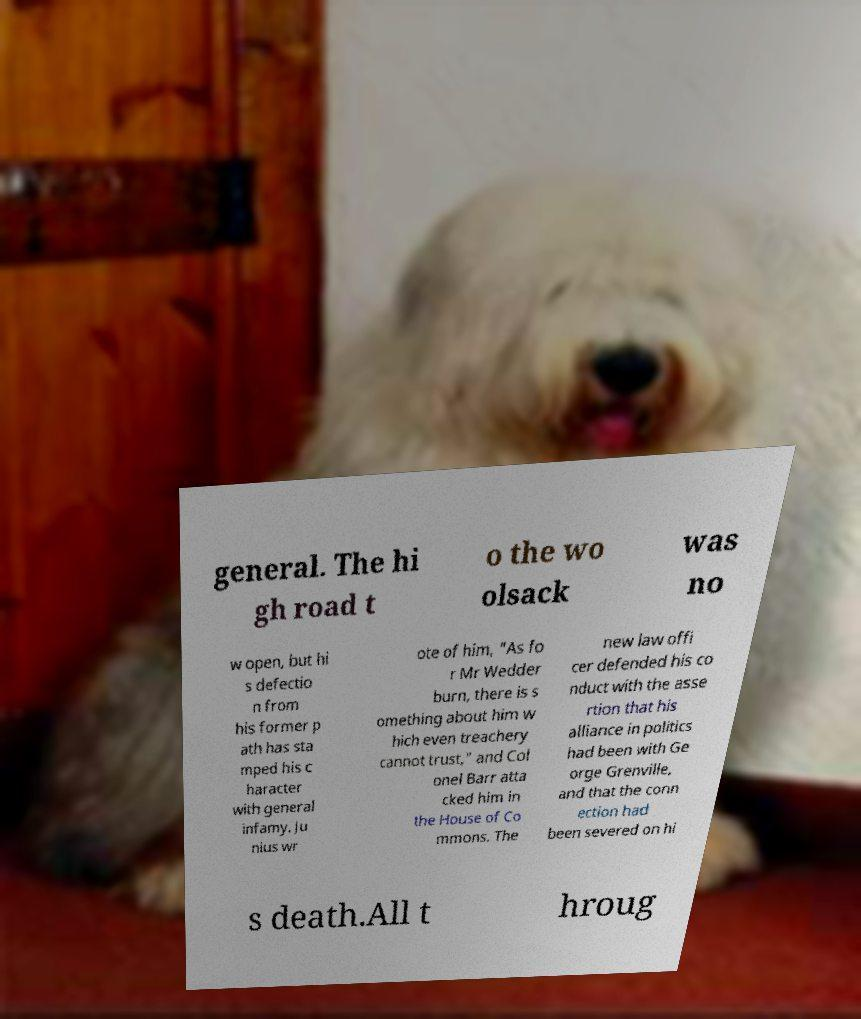Please read and relay the text visible in this image. What does it say? general. The hi gh road t o the wo olsack was no w open, but hi s defectio n from his former p ath has sta mped his c haracter with general infamy. Ju nius wr ote of him, "As fo r Mr Wedder burn, there is s omething about him w hich even treachery cannot trust," and Col onel Barr atta cked him in the House of Co mmons. The new law offi cer defended his co nduct with the asse rtion that his alliance in politics had been with Ge orge Grenville, and that the conn ection had been severed on hi s death.All t hroug 